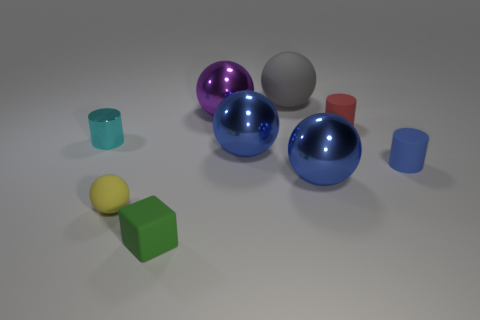Subtract all yellow matte balls. How many balls are left? 4 Subtract all gray cylinders. How many blue spheres are left? 2 Subtract all gray spheres. How many spheres are left? 4 Subtract 3 balls. How many balls are left? 2 Subtract all yellow cylinders. Subtract all gray balls. How many cylinders are left? 3 Subtract all cylinders. How many objects are left? 6 Subtract all tiny brown shiny cubes. Subtract all big gray objects. How many objects are left? 8 Add 2 rubber cylinders. How many rubber cylinders are left? 4 Add 4 large blue metal spheres. How many large blue metal spheres exist? 6 Subtract 0 brown balls. How many objects are left? 9 